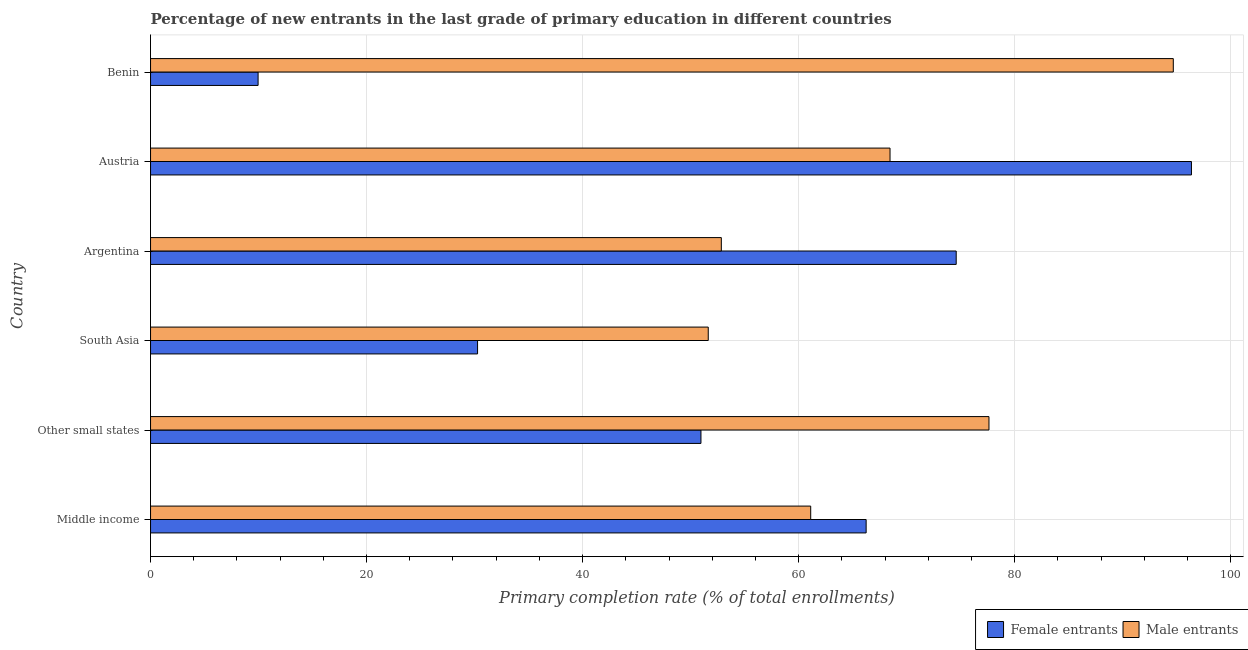How many different coloured bars are there?
Offer a very short reply. 2. How many groups of bars are there?
Ensure brevity in your answer.  6. Are the number of bars per tick equal to the number of legend labels?
Your answer should be very brief. Yes. Are the number of bars on each tick of the Y-axis equal?
Your response must be concise. Yes. How many bars are there on the 4th tick from the bottom?
Offer a very short reply. 2. What is the label of the 6th group of bars from the top?
Your answer should be compact. Middle income. What is the primary completion rate of female entrants in Austria?
Ensure brevity in your answer.  96.36. Across all countries, what is the maximum primary completion rate of female entrants?
Give a very brief answer. 96.36. Across all countries, what is the minimum primary completion rate of male entrants?
Give a very brief answer. 51.63. In which country was the primary completion rate of male entrants maximum?
Provide a short and direct response. Benin. In which country was the primary completion rate of female entrants minimum?
Ensure brevity in your answer.  Benin. What is the total primary completion rate of female entrants in the graph?
Your answer should be very brief. 328.38. What is the difference between the primary completion rate of male entrants in Benin and that in Middle income?
Offer a very short reply. 33.57. What is the difference between the primary completion rate of female entrants in Argentina and the primary completion rate of male entrants in Benin?
Your answer should be compact. -20.1. What is the average primary completion rate of female entrants per country?
Provide a succinct answer. 54.73. What is the difference between the primary completion rate of female entrants and primary completion rate of male entrants in Middle income?
Offer a terse response. 5.13. What is the ratio of the primary completion rate of female entrants in Benin to that in South Asia?
Provide a succinct answer. 0.33. Is the primary completion rate of male entrants in Argentina less than that in Austria?
Keep it short and to the point. Yes. Is the difference between the primary completion rate of male entrants in Benin and South Asia greater than the difference between the primary completion rate of female entrants in Benin and South Asia?
Offer a terse response. Yes. What is the difference between the highest and the second highest primary completion rate of male entrants?
Provide a succinct answer. 17.07. What is the difference between the highest and the lowest primary completion rate of male entrants?
Give a very brief answer. 43.05. In how many countries, is the primary completion rate of female entrants greater than the average primary completion rate of female entrants taken over all countries?
Keep it short and to the point. 3. What does the 1st bar from the top in Benin represents?
Make the answer very short. Male entrants. What does the 1st bar from the bottom in Austria represents?
Your answer should be compact. Female entrants. Are all the bars in the graph horizontal?
Keep it short and to the point. Yes. How many countries are there in the graph?
Keep it short and to the point. 6. What is the difference between two consecutive major ticks on the X-axis?
Give a very brief answer. 20. Does the graph contain any zero values?
Your answer should be compact. No. How are the legend labels stacked?
Your answer should be very brief. Horizontal. What is the title of the graph?
Provide a succinct answer. Percentage of new entrants in the last grade of primary education in different countries. What is the label or title of the X-axis?
Provide a succinct answer. Primary completion rate (% of total enrollments). What is the label or title of the Y-axis?
Ensure brevity in your answer.  Country. What is the Primary completion rate (% of total enrollments) in Female entrants in Middle income?
Offer a terse response. 66.25. What is the Primary completion rate (% of total enrollments) of Male entrants in Middle income?
Offer a very short reply. 61.12. What is the Primary completion rate (% of total enrollments) in Female entrants in Other small states?
Provide a succinct answer. 50.96. What is the Primary completion rate (% of total enrollments) in Male entrants in Other small states?
Offer a terse response. 77.62. What is the Primary completion rate (% of total enrollments) of Female entrants in South Asia?
Ensure brevity in your answer.  30.27. What is the Primary completion rate (% of total enrollments) of Male entrants in South Asia?
Offer a very short reply. 51.63. What is the Primary completion rate (% of total enrollments) of Female entrants in Argentina?
Provide a succinct answer. 74.59. What is the Primary completion rate (% of total enrollments) in Male entrants in Argentina?
Make the answer very short. 52.84. What is the Primary completion rate (% of total enrollments) in Female entrants in Austria?
Offer a terse response. 96.36. What is the Primary completion rate (% of total enrollments) in Male entrants in Austria?
Your answer should be very brief. 68.46. What is the Primary completion rate (% of total enrollments) of Female entrants in Benin?
Offer a terse response. 9.96. What is the Primary completion rate (% of total enrollments) in Male entrants in Benin?
Provide a succinct answer. 94.68. Across all countries, what is the maximum Primary completion rate (% of total enrollments) of Female entrants?
Offer a very short reply. 96.36. Across all countries, what is the maximum Primary completion rate (% of total enrollments) in Male entrants?
Your answer should be compact. 94.68. Across all countries, what is the minimum Primary completion rate (% of total enrollments) of Female entrants?
Your answer should be compact. 9.96. Across all countries, what is the minimum Primary completion rate (% of total enrollments) in Male entrants?
Your answer should be very brief. 51.63. What is the total Primary completion rate (% of total enrollments) in Female entrants in the graph?
Your answer should be compact. 328.38. What is the total Primary completion rate (% of total enrollments) of Male entrants in the graph?
Offer a very short reply. 406.35. What is the difference between the Primary completion rate (% of total enrollments) in Female entrants in Middle income and that in Other small states?
Your answer should be very brief. 15.29. What is the difference between the Primary completion rate (% of total enrollments) in Male entrants in Middle income and that in Other small states?
Your answer should be compact. -16.5. What is the difference between the Primary completion rate (% of total enrollments) of Female entrants in Middle income and that in South Asia?
Ensure brevity in your answer.  35.97. What is the difference between the Primary completion rate (% of total enrollments) of Male entrants in Middle income and that in South Asia?
Offer a very short reply. 9.48. What is the difference between the Primary completion rate (% of total enrollments) of Female entrants in Middle income and that in Argentina?
Give a very brief answer. -8.34. What is the difference between the Primary completion rate (% of total enrollments) in Male entrants in Middle income and that in Argentina?
Your response must be concise. 8.27. What is the difference between the Primary completion rate (% of total enrollments) of Female entrants in Middle income and that in Austria?
Give a very brief answer. -30.12. What is the difference between the Primary completion rate (% of total enrollments) of Male entrants in Middle income and that in Austria?
Your response must be concise. -7.34. What is the difference between the Primary completion rate (% of total enrollments) in Female entrants in Middle income and that in Benin?
Your answer should be compact. 56.29. What is the difference between the Primary completion rate (% of total enrollments) in Male entrants in Middle income and that in Benin?
Provide a succinct answer. -33.57. What is the difference between the Primary completion rate (% of total enrollments) in Female entrants in Other small states and that in South Asia?
Your answer should be very brief. 20.68. What is the difference between the Primary completion rate (% of total enrollments) of Male entrants in Other small states and that in South Asia?
Give a very brief answer. 25.99. What is the difference between the Primary completion rate (% of total enrollments) in Female entrants in Other small states and that in Argentina?
Your response must be concise. -23.63. What is the difference between the Primary completion rate (% of total enrollments) in Male entrants in Other small states and that in Argentina?
Give a very brief answer. 24.78. What is the difference between the Primary completion rate (% of total enrollments) of Female entrants in Other small states and that in Austria?
Offer a very short reply. -45.41. What is the difference between the Primary completion rate (% of total enrollments) of Male entrants in Other small states and that in Austria?
Make the answer very short. 9.16. What is the difference between the Primary completion rate (% of total enrollments) in Female entrants in Other small states and that in Benin?
Offer a terse response. 41. What is the difference between the Primary completion rate (% of total enrollments) of Male entrants in Other small states and that in Benin?
Your answer should be compact. -17.07. What is the difference between the Primary completion rate (% of total enrollments) in Female entrants in South Asia and that in Argentina?
Make the answer very short. -44.31. What is the difference between the Primary completion rate (% of total enrollments) of Male entrants in South Asia and that in Argentina?
Your answer should be very brief. -1.21. What is the difference between the Primary completion rate (% of total enrollments) of Female entrants in South Asia and that in Austria?
Give a very brief answer. -66.09. What is the difference between the Primary completion rate (% of total enrollments) of Male entrants in South Asia and that in Austria?
Provide a succinct answer. -16.83. What is the difference between the Primary completion rate (% of total enrollments) of Female entrants in South Asia and that in Benin?
Offer a terse response. 20.32. What is the difference between the Primary completion rate (% of total enrollments) of Male entrants in South Asia and that in Benin?
Provide a short and direct response. -43.05. What is the difference between the Primary completion rate (% of total enrollments) of Female entrants in Argentina and that in Austria?
Your answer should be very brief. -21.78. What is the difference between the Primary completion rate (% of total enrollments) in Male entrants in Argentina and that in Austria?
Offer a terse response. -15.62. What is the difference between the Primary completion rate (% of total enrollments) in Female entrants in Argentina and that in Benin?
Provide a short and direct response. 64.63. What is the difference between the Primary completion rate (% of total enrollments) in Male entrants in Argentina and that in Benin?
Your answer should be compact. -41.84. What is the difference between the Primary completion rate (% of total enrollments) of Female entrants in Austria and that in Benin?
Give a very brief answer. 86.41. What is the difference between the Primary completion rate (% of total enrollments) in Male entrants in Austria and that in Benin?
Offer a terse response. -26.22. What is the difference between the Primary completion rate (% of total enrollments) in Female entrants in Middle income and the Primary completion rate (% of total enrollments) in Male entrants in Other small states?
Keep it short and to the point. -11.37. What is the difference between the Primary completion rate (% of total enrollments) of Female entrants in Middle income and the Primary completion rate (% of total enrollments) of Male entrants in South Asia?
Make the answer very short. 14.62. What is the difference between the Primary completion rate (% of total enrollments) in Female entrants in Middle income and the Primary completion rate (% of total enrollments) in Male entrants in Argentina?
Keep it short and to the point. 13.41. What is the difference between the Primary completion rate (% of total enrollments) of Female entrants in Middle income and the Primary completion rate (% of total enrollments) of Male entrants in Austria?
Make the answer very short. -2.21. What is the difference between the Primary completion rate (% of total enrollments) in Female entrants in Middle income and the Primary completion rate (% of total enrollments) in Male entrants in Benin?
Make the answer very short. -28.44. What is the difference between the Primary completion rate (% of total enrollments) of Female entrants in Other small states and the Primary completion rate (% of total enrollments) of Male entrants in South Asia?
Provide a succinct answer. -0.68. What is the difference between the Primary completion rate (% of total enrollments) of Female entrants in Other small states and the Primary completion rate (% of total enrollments) of Male entrants in Argentina?
Provide a short and direct response. -1.89. What is the difference between the Primary completion rate (% of total enrollments) in Female entrants in Other small states and the Primary completion rate (% of total enrollments) in Male entrants in Austria?
Offer a very short reply. -17.5. What is the difference between the Primary completion rate (% of total enrollments) of Female entrants in Other small states and the Primary completion rate (% of total enrollments) of Male entrants in Benin?
Keep it short and to the point. -43.73. What is the difference between the Primary completion rate (% of total enrollments) of Female entrants in South Asia and the Primary completion rate (% of total enrollments) of Male entrants in Argentina?
Provide a succinct answer. -22.57. What is the difference between the Primary completion rate (% of total enrollments) in Female entrants in South Asia and the Primary completion rate (% of total enrollments) in Male entrants in Austria?
Your answer should be compact. -38.19. What is the difference between the Primary completion rate (% of total enrollments) in Female entrants in South Asia and the Primary completion rate (% of total enrollments) in Male entrants in Benin?
Give a very brief answer. -64.41. What is the difference between the Primary completion rate (% of total enrollments) of Female entrants in Argentina and the Primary completion rate (% of total enrollments) of Male entrants in Austria?
Keep it short and to the point. 6.13. What is the difference between the Primary completion rate (% of total enrollments) in Female entrants in Argentina and the Primary completion rate (% of total enrollments) in Male entrants in Benin?
Make the answer very short. -20.1. What is the difference between the Primary completion rate (% of total enrollments) in Female entrants in Austria and the Primary completion rate (% of total enrollments) in Male entrants in Benin?
Ensure brevity in your answer.  1.68. What is the average Primary completion rate (% of total enrollments) of Female entrants per country?
Provide a succinct answer. 54.73. What is the average Primary completion rate (% of total enrollments) in Male entrants per country?
Ensure brevity in your answer.  67.72. What is the difference between the Primary completion rate (% of total enrollments) in Female entrants and Primary completion rate (% of total enrollments) in Male entrants in Middle income?
Offer a terse response. 5.13. What is the difference between the Primary completion rate (% of total enrollments) of Female entrants and Primary completion rate (% of total enrollments) of Male entrants in Other small states?
Your response must be concise. -26.66. What is the difference between the Primary completion rate (% of total enrollments) of Female entrants and Primary completion rate (% of total enrollments) of Male entrants in South Asia?
Keep it short and to the point. -21.36. What is the difference between the Primary completion rate (% of total enrollments) of Female entrants and Primary completion rate (% of total enrollments) of Male entrants in Argentina?
Give a very brief answer. 21.75. What is the difference between the Primary completion rate (% of total enrollments) of Female entrants and Primary completion rate (% of total enrollments) of Male entrants in Austria?
Provide a succinct answer. 27.9. What is the difference between the Primary completion rate (% of total enrollments) in Female entrants and Primary completion rate (% of total enrollments) in Male entrants in Benin?
Your response must be concise. -84.73. What is the ratio of the Primary completion rate (% of total enrollments) in Female entrants in Middle income to that in Other small states?
Ensure brevity in your answer.  1.3. What is the ratio of the Primary completion rate (% of total enrollments) of Male entrants in Middle income to that in Other small states?
Keep it short and to the point. 0.79. What is the ratio of the Primary completion rate (% of total enrollments) in Female entrants in Middle income to that in South Asia?
Your answer should be very brief. 2.19. What is the ratio of the Primary completion rate (% of total enrollments) in Male entrants in Middle income to that in South Asia?
Provide a short and direct response. 1.18. What is the ratio of the Primary completion rate (% of total enrollments) in Female entrants in Middle income to that in Argentina?
Ensure brevity in your answer.  0.89. What is the ratio of the Primary completion rate (% of total enrollments) of Male entrants in Middle income to that in Argentina?
Give a very brief answer. 1.16. What is the ratio of the Primary completion rate (% of total enrollments) of Female entrants in Middle income to that in Austria?
Give a very brief answer. 0.69. What is the ratio of the Primary completion rate (% of total enrollments) of Male entrants in Middle income to that in Austria?
Offer a very short reply. 0.89. What is the ratio of the Primary completion rate (% of total enrollments) in Female entrants in Middle income to that in Benin?
Your answer should be very brief. 6.65. What is the ratio of the Primary completion rate (% of total enrollments) of Male entrants in Middle income to that in Benin?
Give a very brief answer. 0.65. What is the ratio of the Primary completion rate (% of total enrollments) in Female entrants in Other small states to that in South Asia?
Keep it short and to the point. 1.68. What is the ratio of the Primary completion rate (% of total enrollments) in Male entrants in Other small states to that in South Asia?
Provide a short and direct response. 1.5. What is the ratio of the Primary completion rate (% of total enrollments) of Female entrants in Other small states to that in Argentina?
Offer a very short reply. 0.68. What is the ratio of the Primary completion rate (% of total enrollments) of Male entrants in Other small states to that in Argentina?
Give a very brief answer. 1.47. What is the ratio of the Primary completion rate (% of total enrollments) in Female entrants in Other small states to that in Austria?
Your answer should be compact. 0.53. What is the ratio of the Primary completion rate (% of total enrollments) in Male entrants in Other small states to that in Austria?
Offer a terse response. 1.13. What is the ratio of the Primary completion rate (% of total enrollments) in Female entrants in Other small states to that in Benin?
Your answer should be compact. 5.12. What is the ratio of the Primary completion rate (% of total enrollments) of Male entrants in Other small states to that in Benin?
Provide a short and direct response. 0.82. What is the ratio of the Primary completion rate (% of total enrollments) in Female entrants in South Asia to that in Argentina?
Offer a terse response. 0.41. What is the ratio of the Primary completion rate (% of total enrollments) of Male entrants in South Asia to that in Argentina?
Offer a very short reply. 0.98. What is the ratio of the Primary completion rate (% of total enrollments) of Female entrants in South Asia to that in Austria?
Keep it short and to the point. 0.31. What is the ratio of the Primary completion rate (% of total enrollments) of Male entrants in South Asia to that in Austria?
Give a very brief answer. 0.75. What is the ratio of the Primary completion rate (% of total enrollments) in Female entrants in South Asia to that in Benin?
Make the answer very short. 3.04. What is the ratio of the Primary completion rate (% of total enrollments) in Male entrants in South Asia to that in Benin?
Offer a very short reply. 0.55. What is the ratio of the Primary completion rate (% of total enrollments) in Female entrants in Argentina to that in Austria?
Your response must be concise. 0.77. What is the ratio of the Primary completion rate (% of total enrollments) in Male entrants in Argentina to that in Austria?
Your answer should be very brief. 0.77. What is the ratio of the Primary completion rate (% of total enrollments) of Female entrants in Argentina to that in Benin?
Your answer should be compact. 7.49. What is the ratio of the Primary completion rate (% of total enrollments) of Male entrants in Argentina to that in Benin?
Provide a succinct answer. 0.56. What is the ratio of the Primary completion rate (% of total enrollments) in Female entrants in Austria to that in Benin?
Your answer should be very brief. 9.68. What is the ratio of the Primary completion rate (% of total enrollments) of Male entrants in Austria to that in Benin?
Your response must be concise. 0.72. What is the difference between the highest and the second highest Primary completion rate (% of total enrollments) in Female entrants?
Make the answer very short. 21.78. What is the difference between the highest and the second highest Primary completion rate (% of total enrollments) in Male entrants?
Your answer should be compact. 17.07. What is the difference between the highest and the lowest Primary completion rate (% of total enrollments) in Female entrants?
Your response must be concise. 86.41. What is the difference between the highest and the lowest Primary completion rate (% of total enrollments) in Male entrants?
Your answer should be compact. 43.05. 